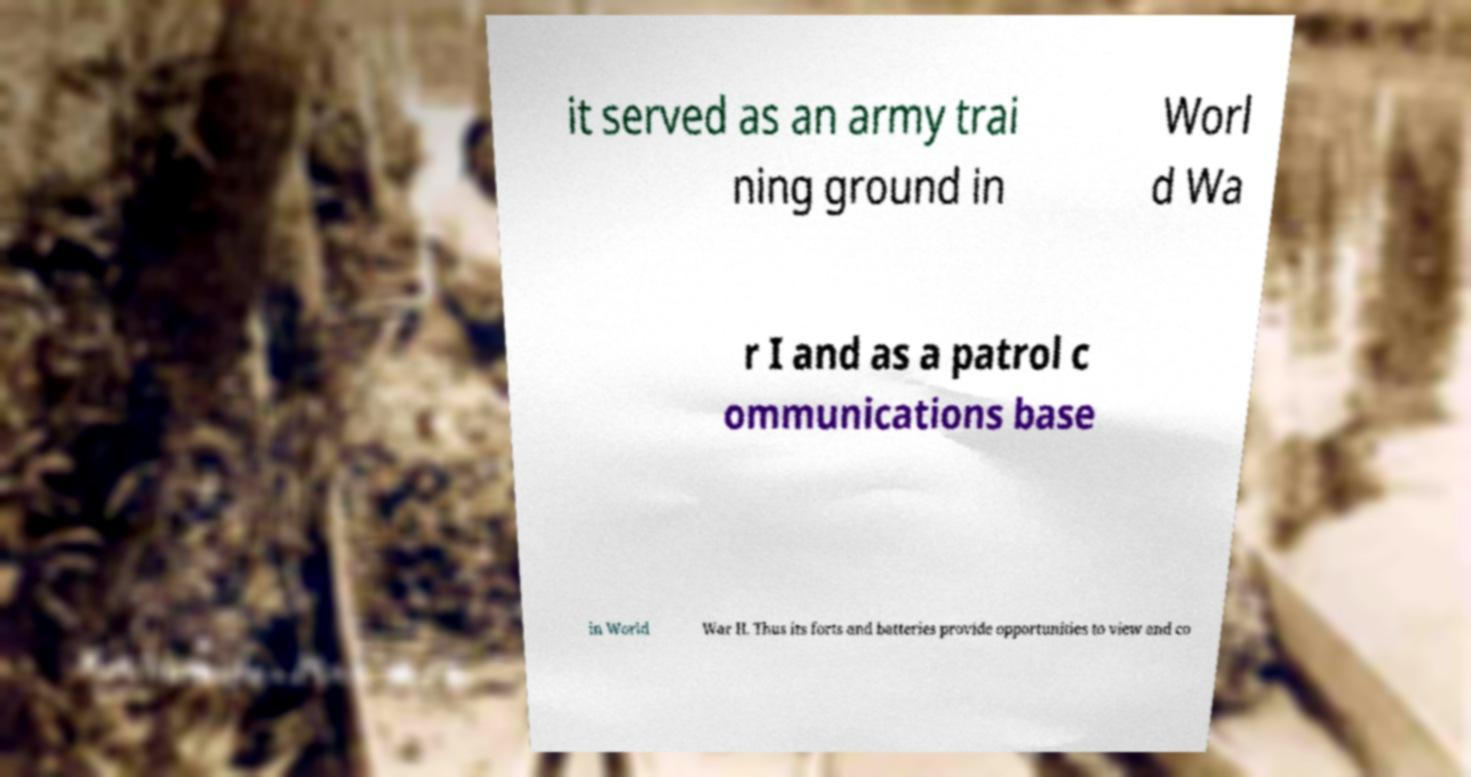Could you assist in decoding the text presented in this image and type it out clearly? it served as an army trai ning ground in Worl d Wa r I and as a patrol c ommunications base in World War II. Thus its forts and batteries provide opportunities to view and co 